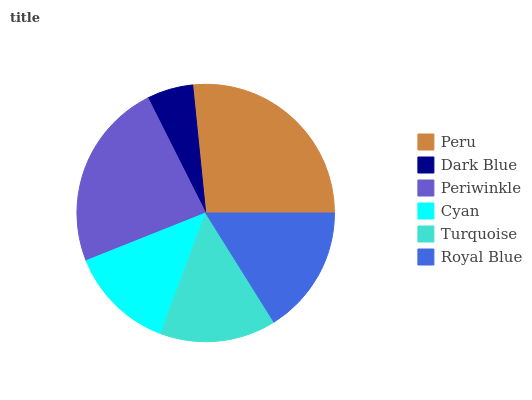Is Dark Blue the minimum?
Answer yes or no. Yes. Is Peru the maximum?
Answer yes or no. Yes. Is Periwinkle the minimum?
Answer yes or no. No. Is Periwinkle the maximum?
Answer yes or no. No. Is Periwinkle greater than Dark Blue?
Answer yes or no. Yes. Is Dark Blue less than Periwinkle?
Answer yes or no. Yes. Is Dark Blue greater than Periwinkle?
Answer yes or no. No. Is Periwinkle less than Dark Blue?
Answer yes or no. No. Is Royal Blue the high median?
Answer yes or no. Yes. Is Turquoise the low median?
Answer yes or no. Yes. Is Periwinkle the high median?
Answer yes or no. No. Is Dark Blue the low median?
Answer yes or no. No. 